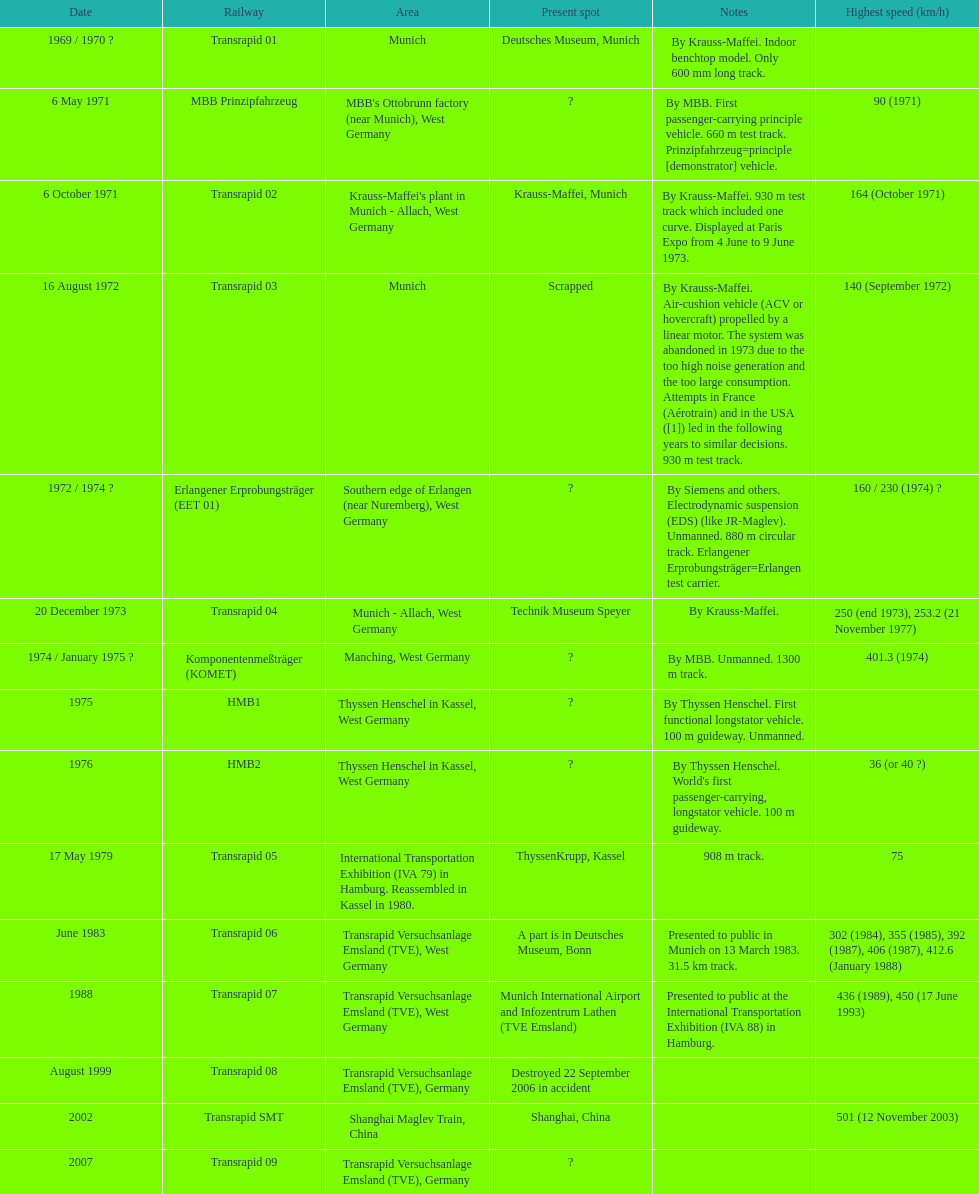Which train has the least top speed? HMB2. 